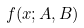Convert formula to latex. <formula><loc_0><loc_0><loc_500><loc_500>f ( x ; A , B )</formula> 